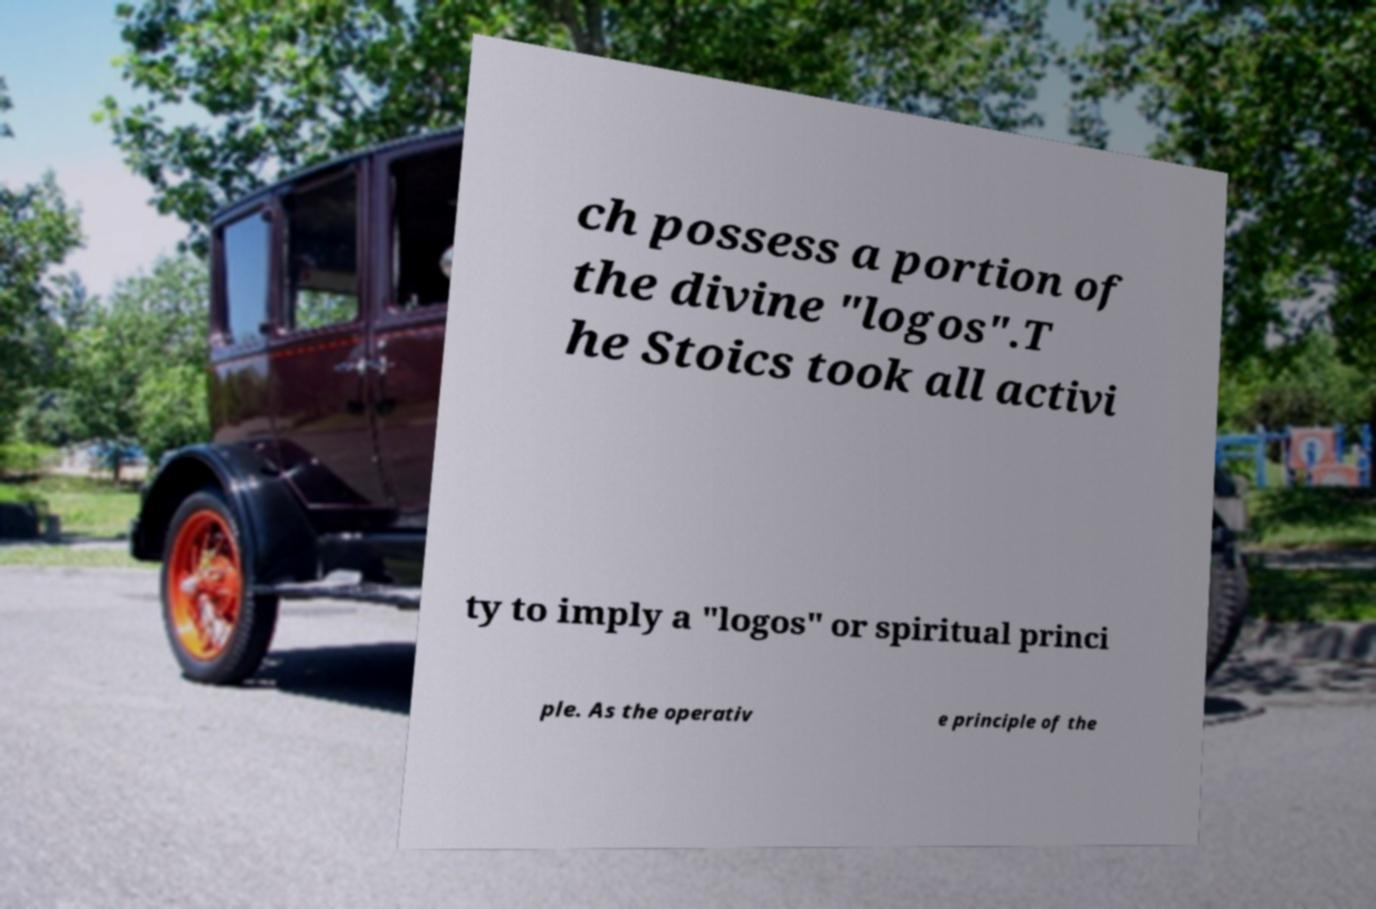What messages or text are displayed in this image? I need them in a readable, typed format. ch possess a portion of the divine "logos".T he Stoics took all activi ty to imply a "logos" or spiritual princi ple. As the operativ e principle of the 